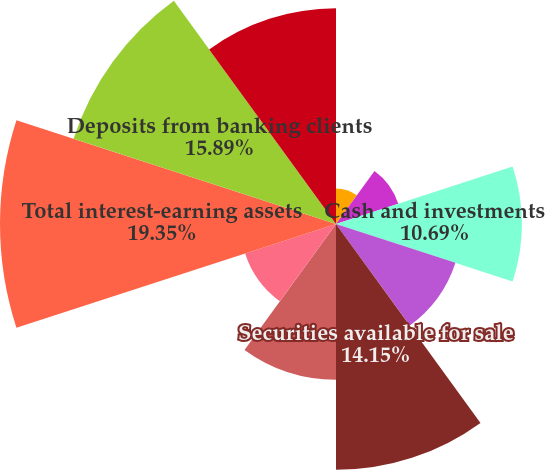Convert chart to OTSL. <chart><loc_0><loc_0><loc_500><loc_500><pie_chart><fcel>Year Ended December 31<fcel>Cash and cash equivalents<fcel>Cash and investments<fcel>Receivables from brokerage<fcel>Securities available for sale<fcel>Securities held to maturity<fcel>Loans to banking clients<fcel>Total interest-earning assets<fcel>Deposits from banking clients<fcel>Payables to brokerage clients<nl><fcel>2.04%<fcel>3.77%<fcel>10.69%<fcel>7.23%<fcel>14.15%<fcel>8.96%<fcel>5.5%<fcel>19.34%<fcel>15.88%<fcel>12.42%<nl></chart> 